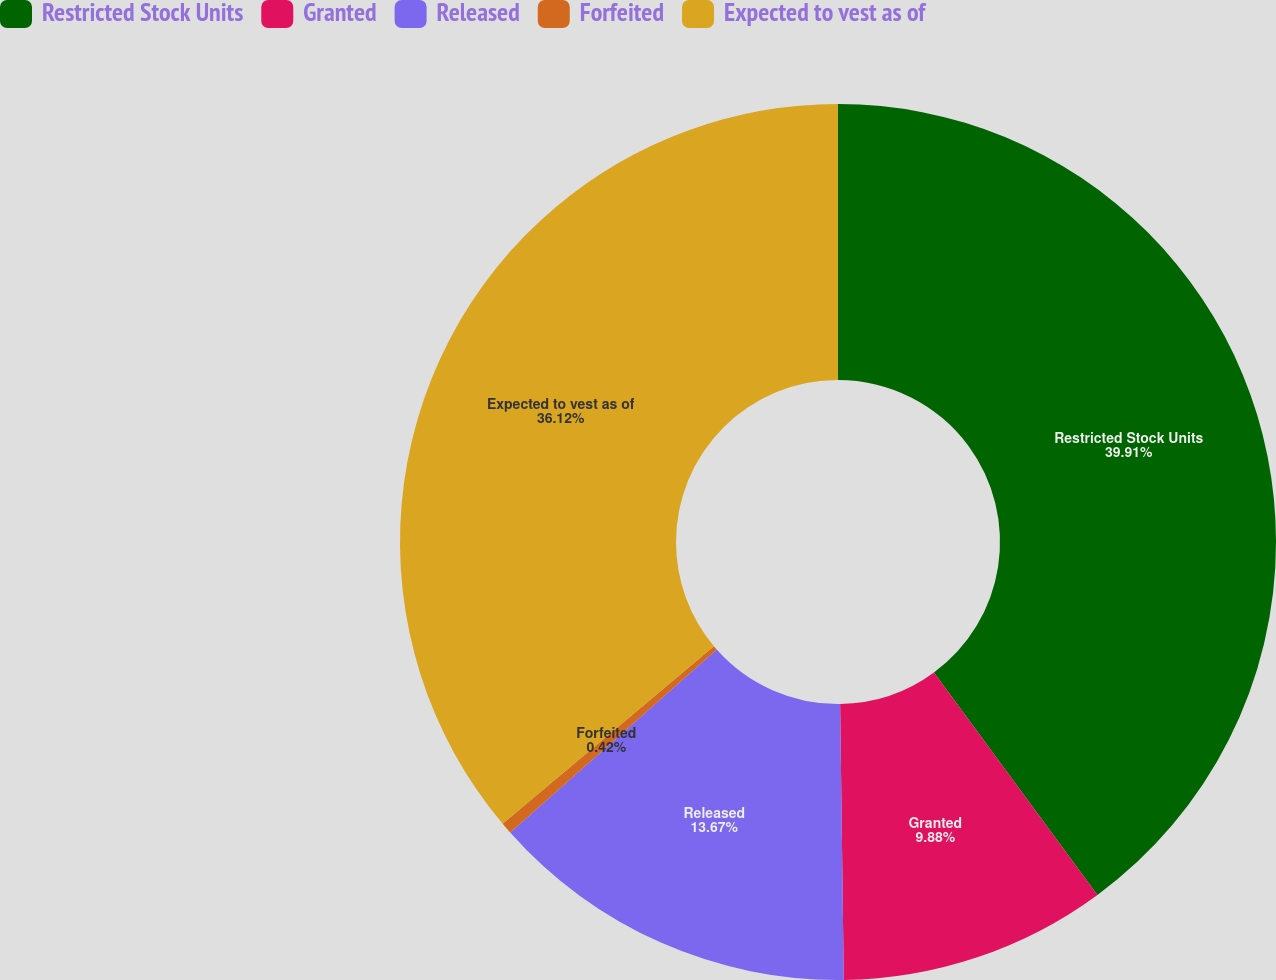Convert chart. <chart><loc_0><loc_0><loc_500><loc_500><pie_chart><fcel>Restricted Stock Units<fcel>Granted<fcel>Released<fcel>Forfeited<fcel>Expected to vest as of<nl><fcel>39.91%<fcel>9.88%<fcel>13.67%<fcel>0.42%<fcel>36.12%<nl></chart> 